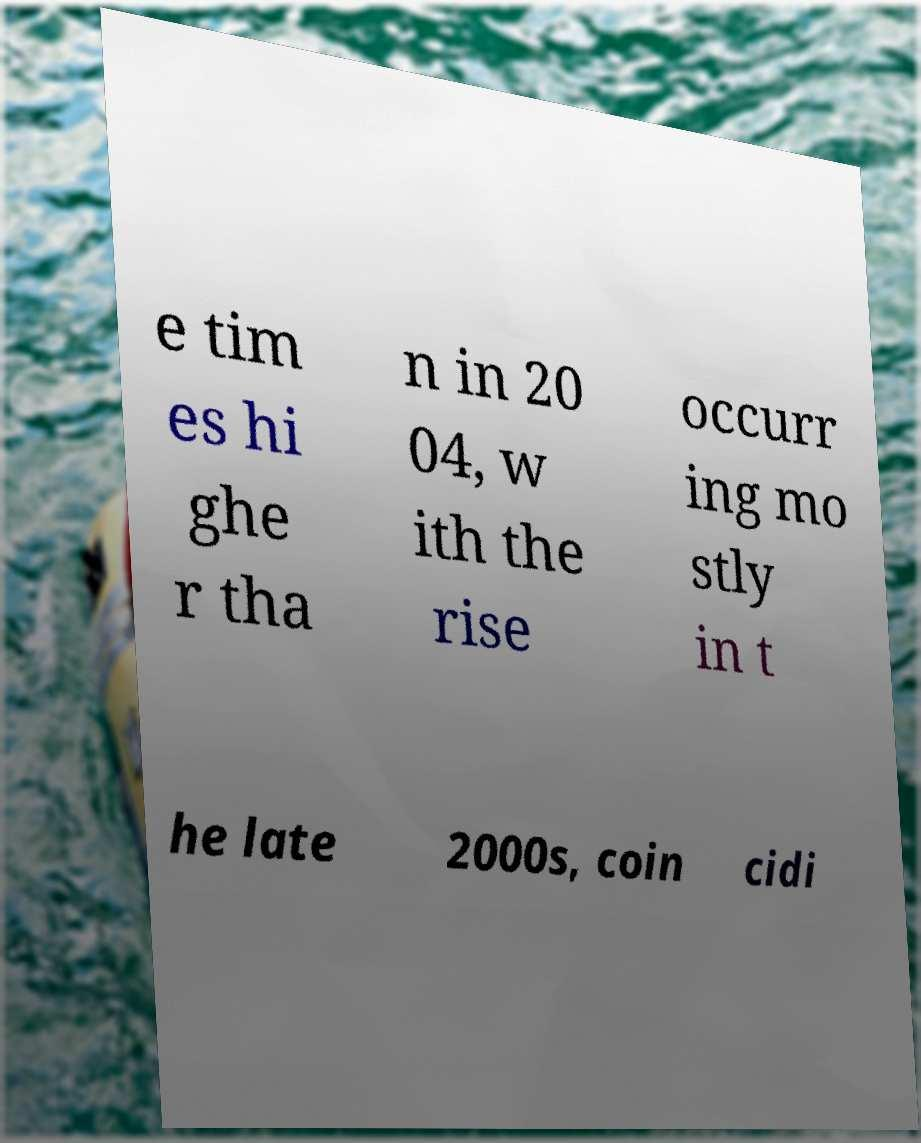There's text embedded in this image that I need extracted. Can you transcribe it verbatim? e tim es hi ghe r tha n in 20 04, w ith the rise occurr ing mo stly in t he late 2000s, coin cidi 